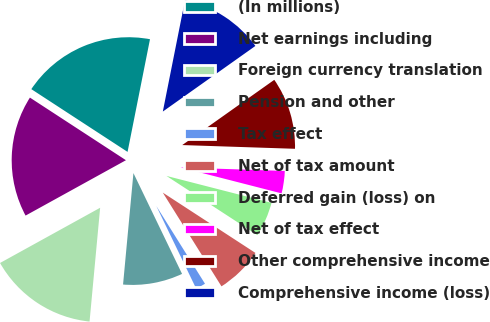Convert chart. <chart><loc_0><loc_0><loc_500><loc_500><pie_chart><fcel>(In millions)<fcel>Net earnings including<fcel>Foreign currency translation<fcel>Pension and other<fcel>Tax effect<fcel>Net of tax amount<fcel>Deferred gain (loss) on<fcel>Net of tax effect<fcel>Other comprehensive income<fcel>Comprehensive income (loss)<nl><fcel>18.93%<fcel>17.22%<fcel>15.5%<fcel>8.63%<fcel>1.75%<fcel>6.91%<fcel>5.19%<fcel>3.47%<fcel>10.34%<fcel>12.06%<nl></chart> 